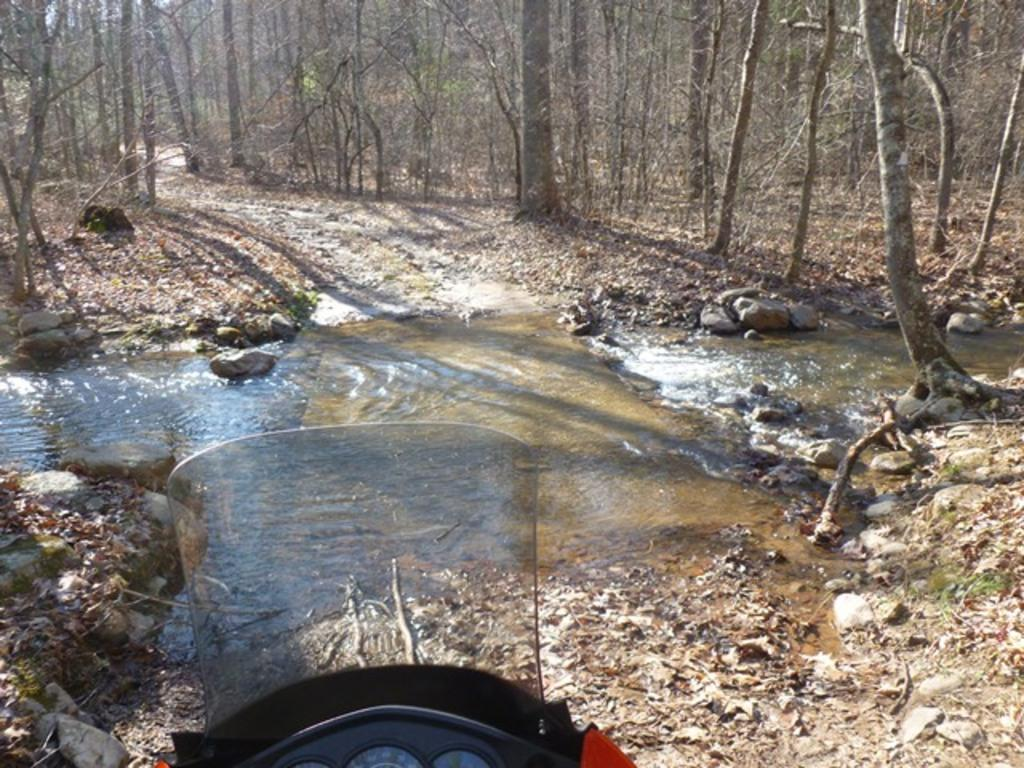What is the primary natural element in the image? There is flowing water in the image. What type of vegetation is present in the image? There are trees and leaves in the image. What other objects can be seen in the image? There are stones and a vehicle partially visible at the bottom of the image. How many legs can be seen on the leaf in the image? There are no legs on the leaf in the image, as leaves are plant parts and do not have legs. 